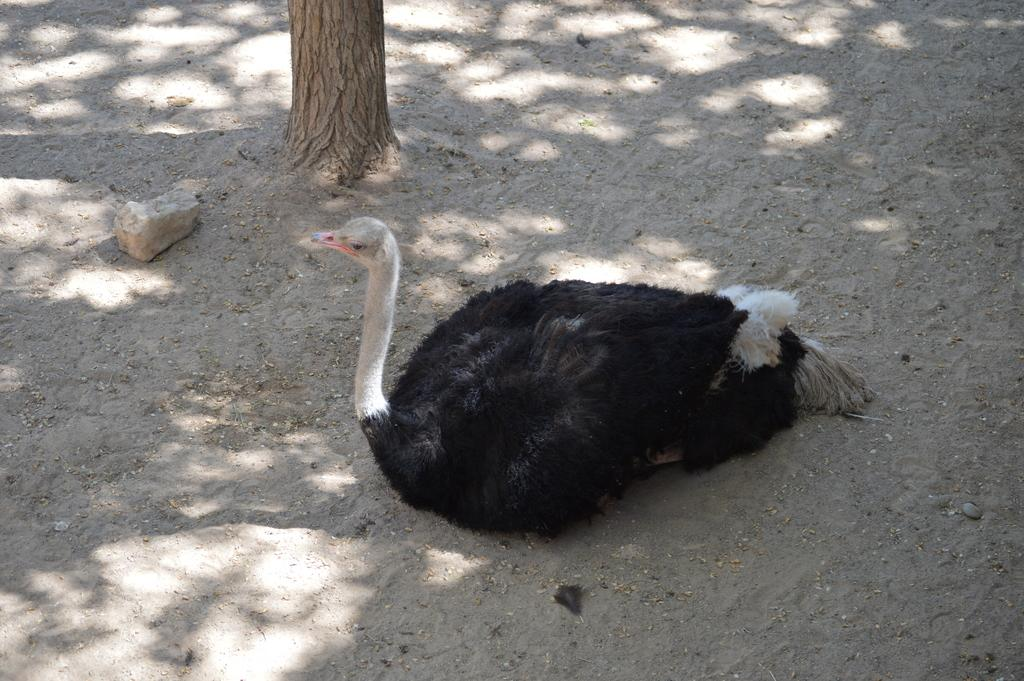What animal is the main subject of the image? There is an ostrich in the image. What is the ostrich doing in the image? The ostrich is sitting on the ground. What other objects can be seen in the image? There is a rock and a tree trunk in the image. What type of prose is the ostrich reading in the image? There is no prose or reading material present in the image; it features an ostrich sitting on the ground, a rock, and a tree trunk. 